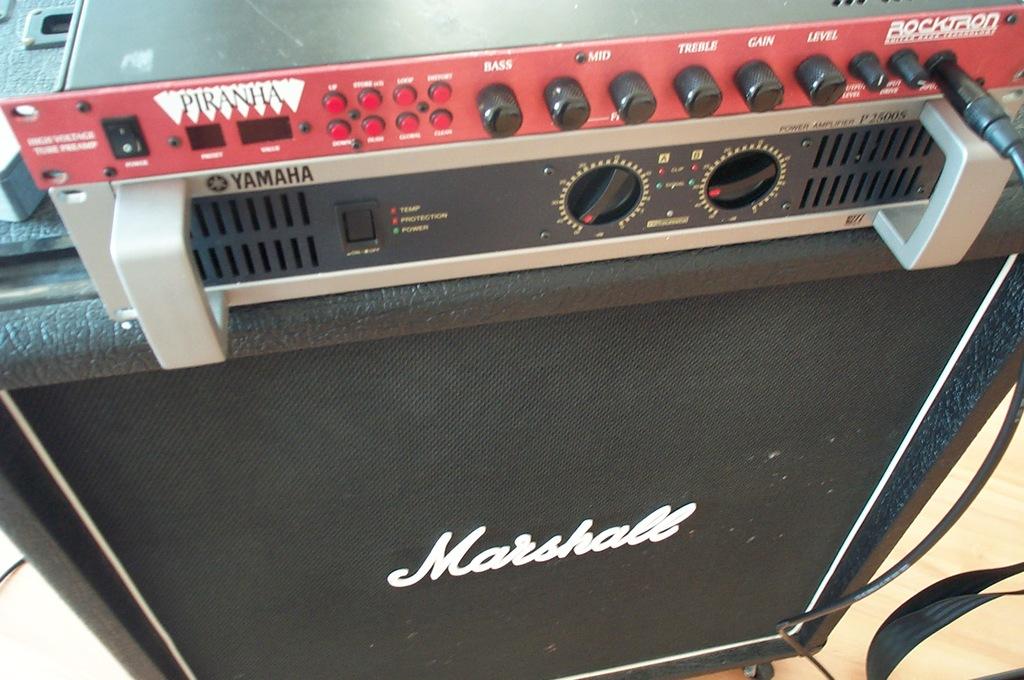What brand of amp is this?
Your answer should be very brief. Marshall. What is the name of the board on top?
Your answer should be compact. Piranha. 